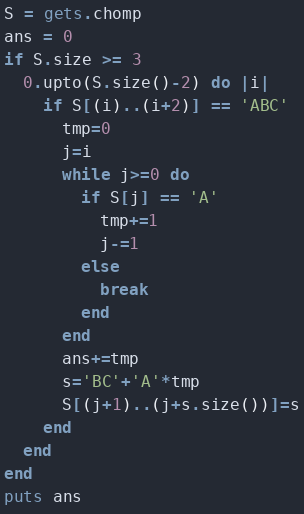Convert code to text. <code><loc_0><loc_0><loc_500><loc_500><_Ruby_>S = gets.chomp
ans = 0
if S.size >= 3
  0.upto(S.size()-2) do |i|
    if S[(i)..(i+2)] == 'ABC'
      tmp=0
      j=i
      while j>=0 do
        if S[j] == 'A'
          tmp+=1
          j-=1
        else
          break
        end
      end
      ans+=tmp
      s='BC'+'A'*tmp
      S[(j+1)..(j+s.size())]=s
    end
  end
end
puts ans</code> 